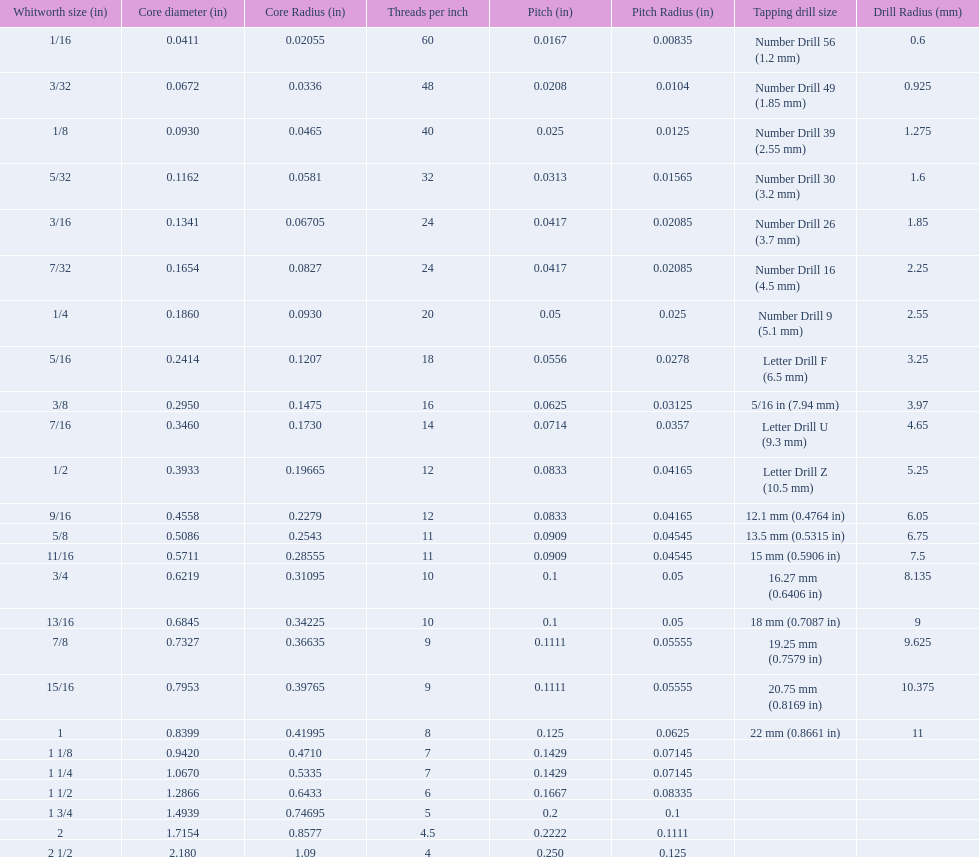What is the next whitworth size (in) below 1/8? 5/32. 